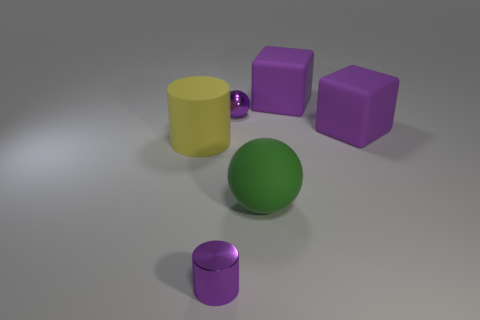Subtract 1 cylinders. How many cylinders are left? 1 Add 1 big green rubber balls. How many big green rubber balls are left? 2 Add 5 balls. How many balls exist? 7 Add 2 small metal things. How many objects exist? 8 Subtract 1 green spheres. How many objects are left? 5 Subtract all blocks. How many objects are left? 4 Subtract all yellow cylinders. Subtract all gray cubes. How many cylinders are left? 1 Subtract all purple cubes. How many green cylinders are left? 0 Subtract all tiny yellow metal things. Subtract all green objects. How many objects are left? 5 